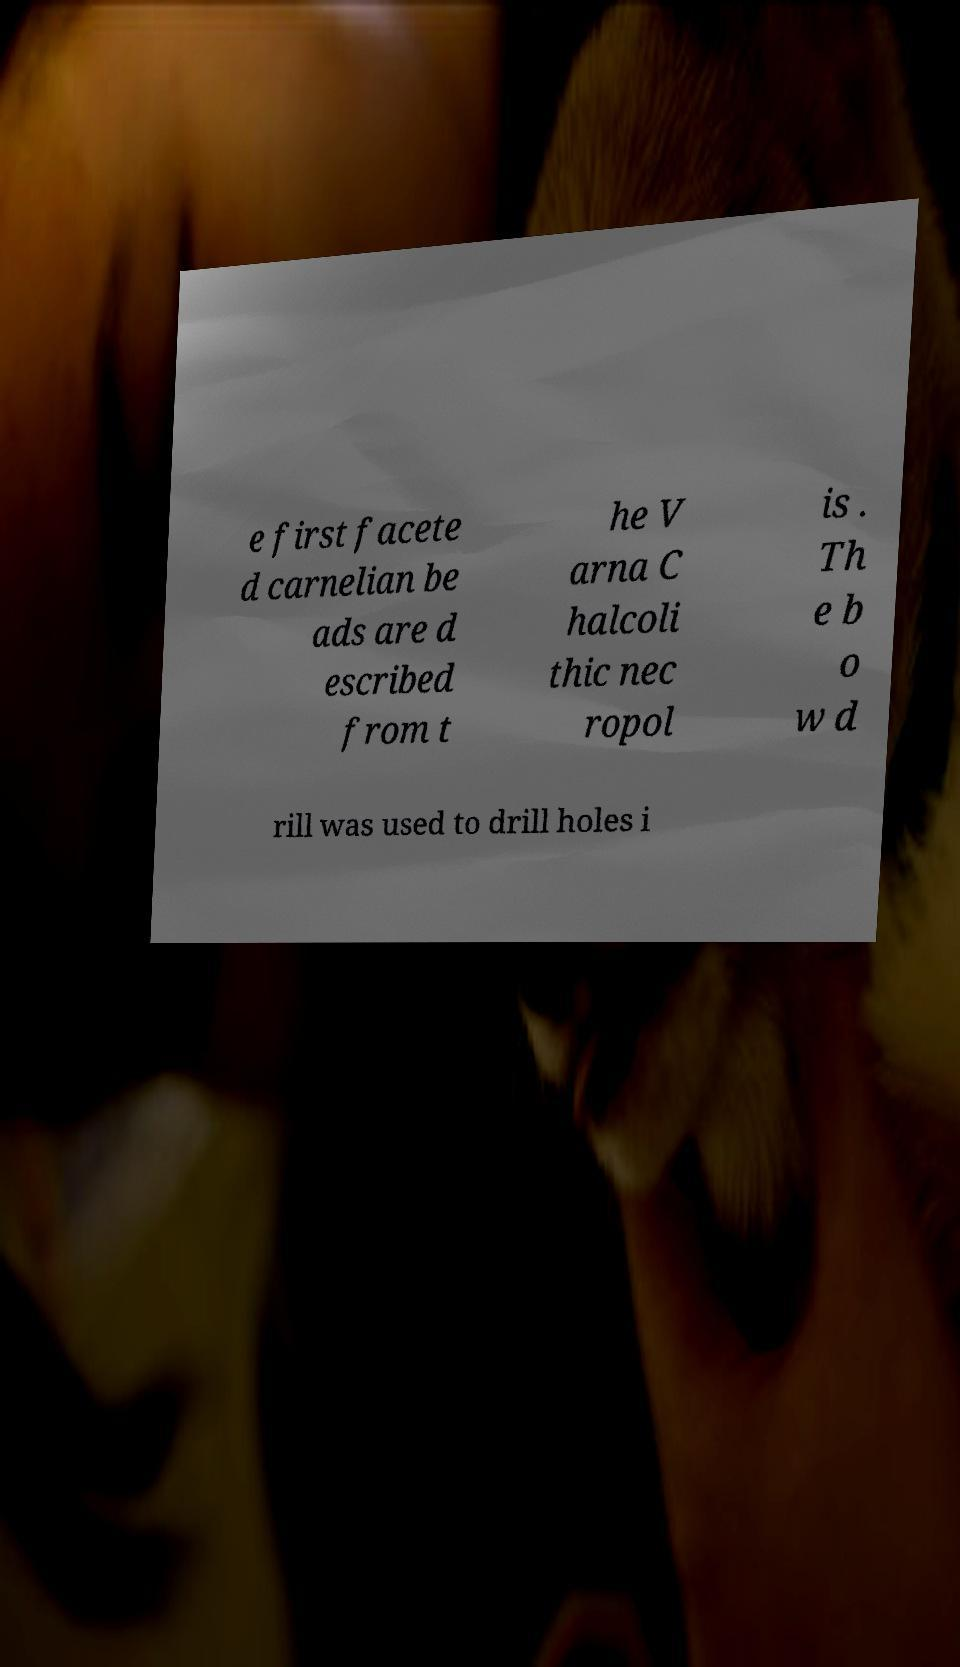Could you extract and type out the text from this image? e first facete d carnelian be ads are d escribed from t he V arna C halcoli thic nec ropol is . Th e b o w d rill was used to drill holes i 